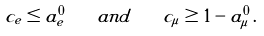<formula> <loc_0><loc_0><loc_500><loc_500>c _ { e } \leq a ^ { 0 } _ { e } \quad a n d \quad c _ { \mu } \geq 1 - a ^ { 0 } _ { \mu } \, .</formula> 